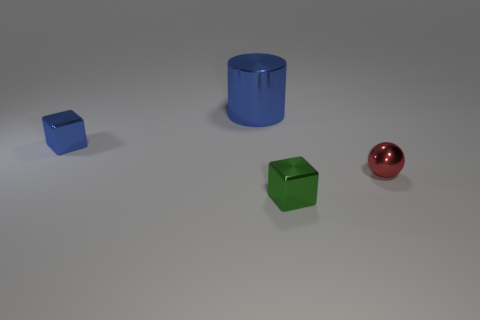Can you explain the lighting in the scene? Certainly! The lighting in this scene appears to be soft and diffused, likely coming from a source above and slightly to the left, judging by the gentle shadows cast below and to the right of each object. The smooth gradients on the objects' surfaces suggest that the light source is somewhat large, providing a uniform illumination that enhances the visual contrast without creating harsh shadows. 